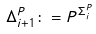<formula> <loc_0><loc_0><loc_500><loc_500>\Delta _ { i + 1 } ^ { P } \colon = { P } ^ { \Sigma _ { i } ^ { P } }</formula> 